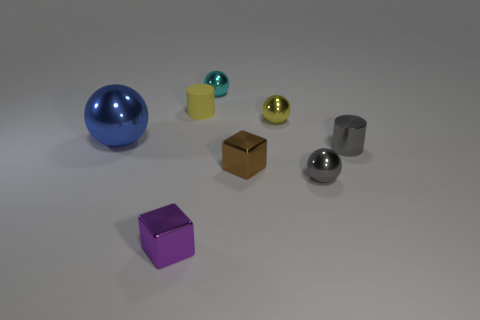Subtract all big metal balls. How many balls are left? 3 Add 2 yellow things. How many objects exist? 10 Subtract 1 balls. How many balls are left? 3 Subtract all gray cylinders. How many cylinders are left? 1 Subtract all cylinders. How many objects are left? 6 Subtract all brown cylinders. Subtract all blue blocks. How many cylinders are left? 2 Subtract all metallic spheres. Subtract all tiny cyan spheres. How many objects are left? 3 Add 7 purple objects. How many purple objects are left? 8 Add 1 large spheres. How many large spheres exist? 2 Subtract 1 yellow balls. How many objects are left? 7 